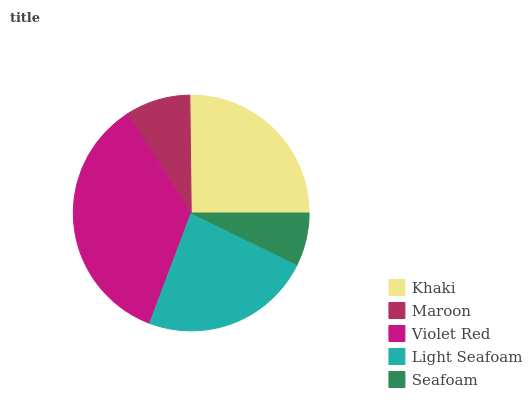Is Seafoam the minimum?
Answer yes or no. Yes. Is Violet Red the maximum?
Answer yes or no. Yes. Is Maroon the minimum?
Answer yes or no. No. Is Maroon the maximum?
Answer yes or no. No. Is Khaki greater than Maroon?
Answer yes or no. Yes. Is Maroon less than Khaki?
Answer yes or no. Yes. Is Maroon greater than Khaki?
Answer yes or no. No. Is Khaki less than Maroon?
Answer yes or no. No. Is Light Seafoam the high median?
Answer yes or no. Yes. Is Light Seafoam the low median?
Answer yes or no. Yes. Is Maroon the high median?
Answer yes or no. No. Is Khaki the low median?
Answer yes or no. No. 